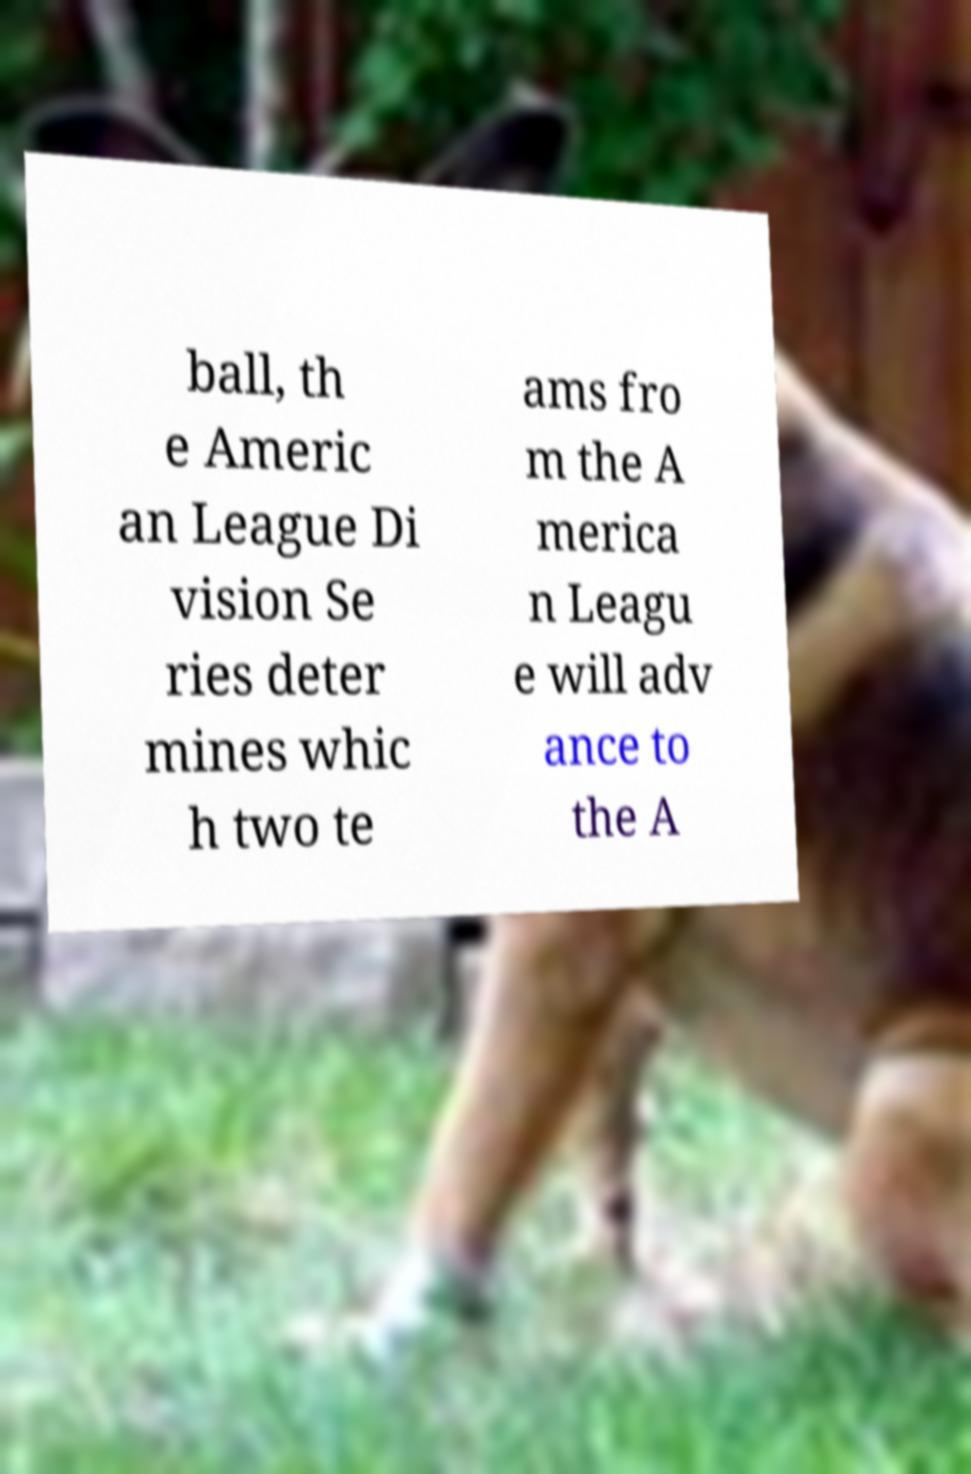Please identify and transcribe the text found in this image. ball, th e Americ an League Di vision Se ries deter mines whic h two te ams fro m the A merica n Leagu e will adv ance to the A 